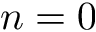<formula> <loc_0><loc_0><loc_500><loc_500>n = 0</formula> 